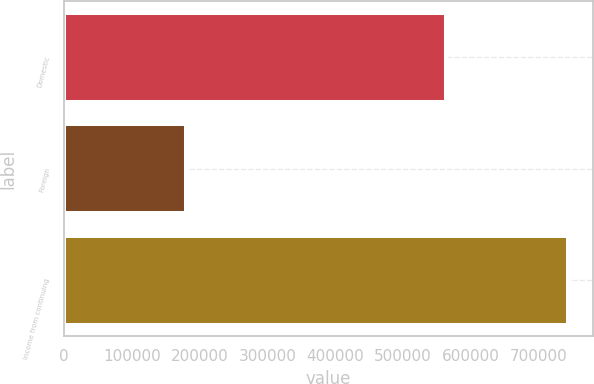Convert chart to OTSL. <chart><loc_0><loc_0><loc_500><loc_500><bar_chart><fcel>Domestic<fcel>Foreign<fcel>Income from continuing<nl><fcel>562758<fcel>180673<fcel>743431<nl></chart> 